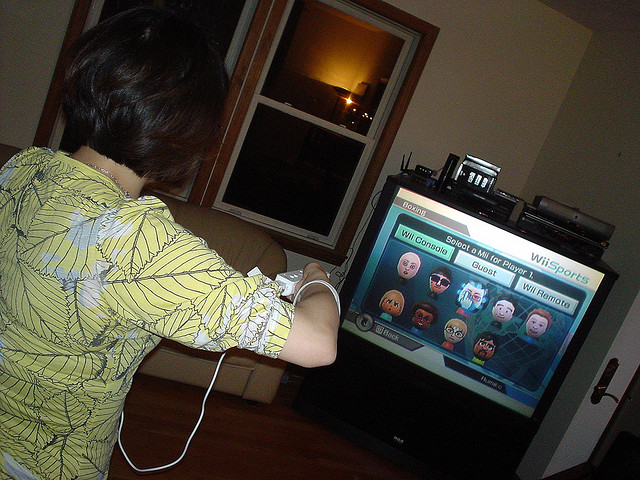Please transcribe the text information in this image. wiisports Remote Guest Console Select Book Wll WII Player for MII Boxng 